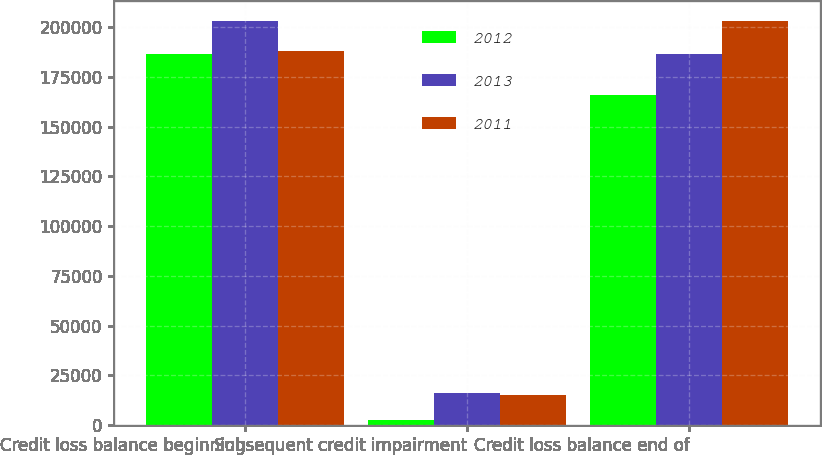Convert chart to OTSL. <chart><loc_0><loc_0><loc_500><loc_500><stacked_bar_chart><ecel><fcel>Credit loss balance beginning<fcel>Subsequent credit impairment<fcel>Credit loss balance end of<nl><fcel>2012<fcel>186722<fcel>2331<fcel>165660<nl><fcel>2013<fcel>202945<fcel>15938<fcel>186722<nl><fcel>2011<fcel>188038<fcel>14846<fcel>202945<nl></chart> 